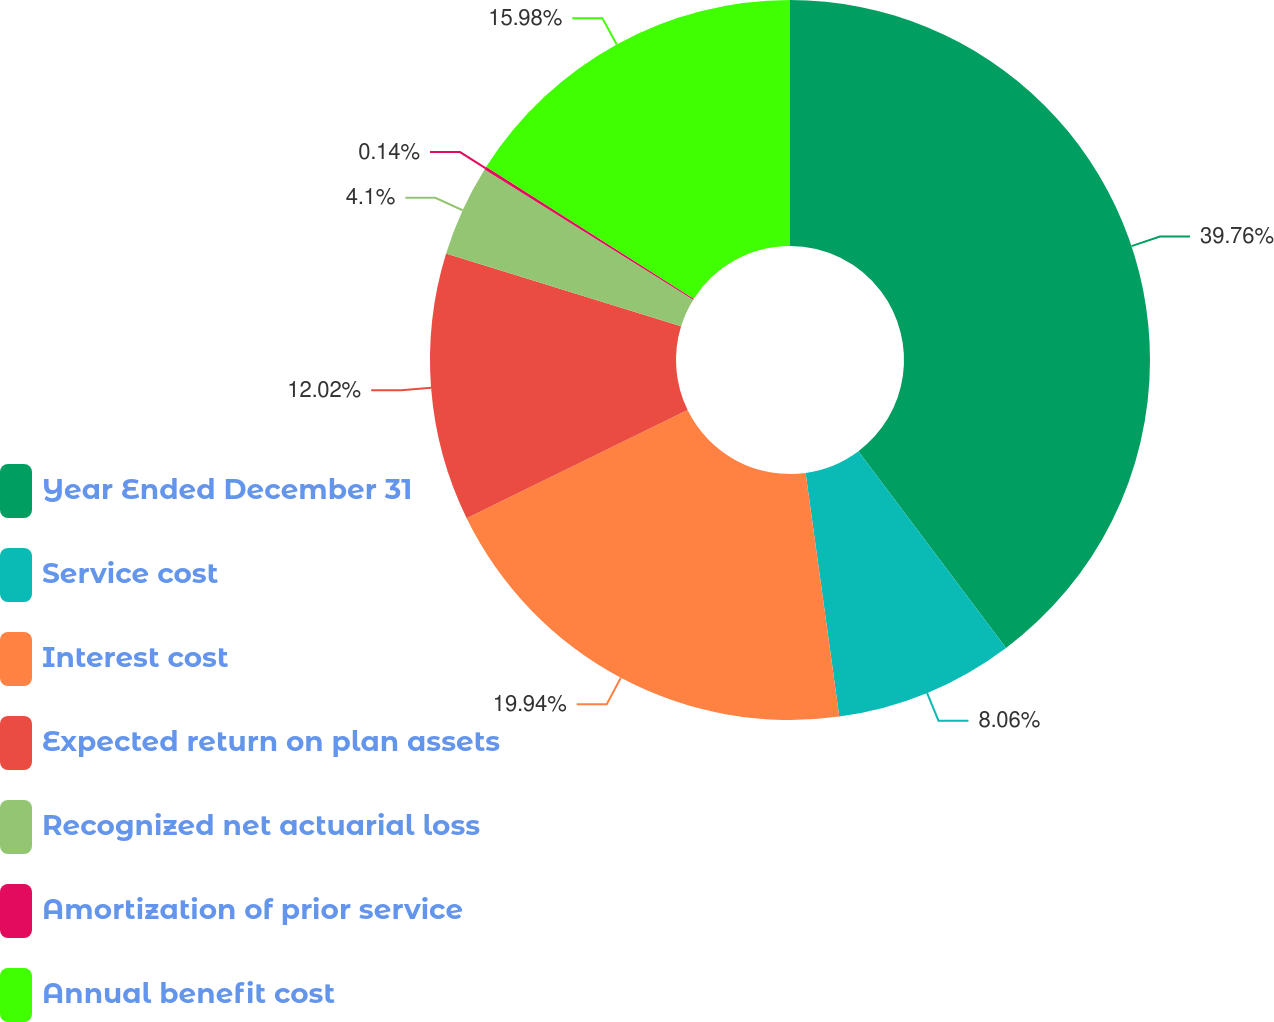<chart> <loc_0><loc_0><loc_500><loc_500><pie_chart><fcel>Year Ended December 31<fcel>Service cost<fcel>Interest cost<fcel>Expected return on plan assets<fcel>Recognized net actuarial loss<fcel>Amortization of prior service<fcel>Annual benefit cost<nl><fcel>39.75%<fcel>8.06%<fcel>19.94%<fcel>12.02%<fcel>4.1%<fcel>0.14%<fcel>15.98%<nl></chart> 